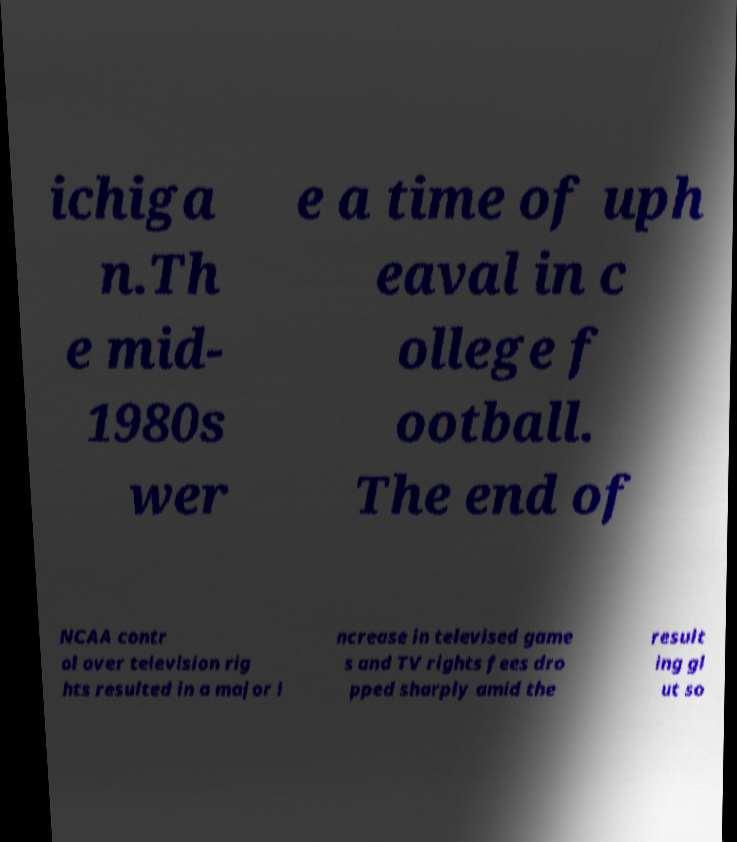For documentation purposes, I need the text within this image transcribed. Could you provide that? ichiga n.Th e mid- 1980s wer e a time of uph eaval in c ollege f ootball. The end of NCAA contr ol over television rig hts resulted in a major i ncrease in televised game s and TV rights fees dro pped sharply amid the result ing gl ut so 